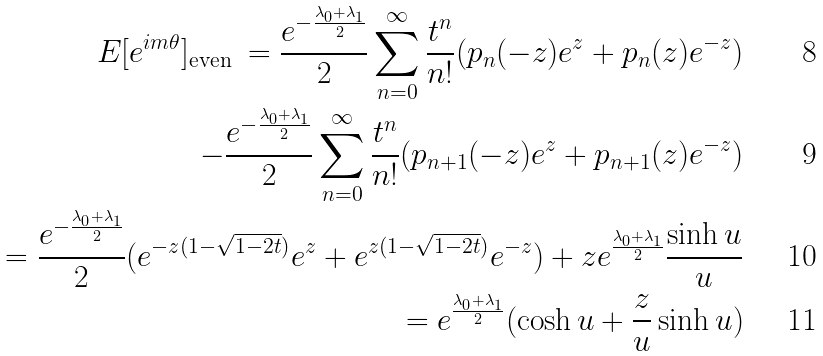Convert formula to latex. <formula><loc_0><loc_0><loc_500><loc_500>E [ e ^ { i m \theta } ] _ { \text {even } } = \frac { e ^ { - \frac { \lambda _ { 0 } + \lambda _ { 1 } } { 2 } } } { 2 } \sum _ { n = 0 } ^ { \infty } \frac { t ^ { n } } { n ! } ( p _ { n } ( - z ) e ^ { z } + p _ { n } ( z ) e ^ { - z } ) \\ - \frac { e ^ { - \frac { \lambda _ { 0 } + \lambda _ { 1 } } { 2 } } } { 2 } \sum _ { n = 0 } ^ { \infty } \frac { t ^ { n } } { n ! } ( p _ { n + 1 } ( - z ) e ^ { z } + p _ { n + 1 } ( z ) e ^ { - z } ) \\ = \frac { e ^ { - \frac { \lambda _ { 0 } + \lambda _ { 1 } } { 2 } } } { 2 } ( e ^ { - z ( 1 - \sqrt { 1 - 2 t } ) } e ^ { z } + e ^ { z ( 1 - \sqrt { 1 - 2 t } ) } e ^ { - z } ) + z e ^ { \frac { \lambda _ { 0 } + \lambda _ { 1 } } { 2 } } \frac { \sinh u } { u } \\ = e ^ { \frac { \lambda _ { 0 } + \lambda _ { 1 } } { 2 } } ( \cosh u + \frac { z } { u } \sinh u )</formula> 